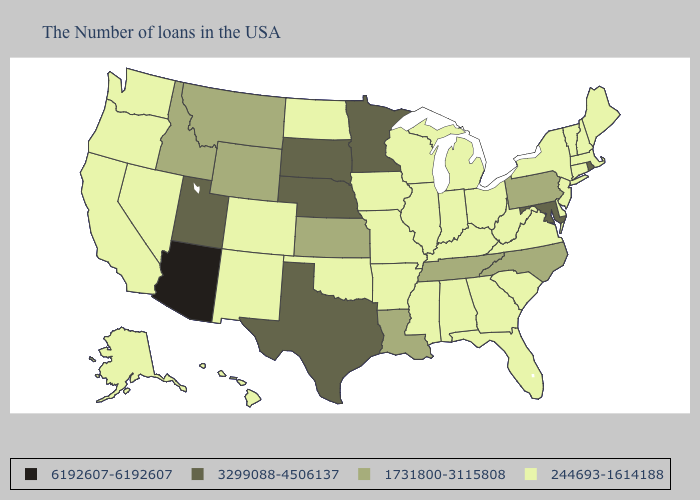What is the lowest value in states that border Louisiana?
Give a very brief answer. 244693-1614188. Does Texas have the highest value in the South?
Give a very brief answer. Yes. What is the lowest value in states that border Ohio?
Quick response, please. 244693-1614188. Which states hav the highest value in the Northeast?
Give a very brief answer. Rhode Island. What is the highest value in the USA?
Write a very short answer. 6192607-6192607. What is the value of Nevada?
Short answer required. 244693-1614188. Name the states that have a value in the range 3299088-4506137?
Quick response, please. Rhode Island, Maryland, Minnesota, Nebraska, Texas, South Dakota, Utah. Which states have the highest value in the USA?
Concise answer only. Arizona. How many symbols are there in the legend?
Answer briefly. 4. Does the first symbol in the legend represent the smallest category?
Be succinct. No. How many symbols are there in the legend?
Concise answer only. 4. Does Virginia have the same value as Rhode Island?
Short answer required. No. Which states have the lowest value in the South?
Concise answer only. Delaware, Virginia, South Carolina, West Virginia, Florida, Georgia, Kentucky, Alabama, Mississippi, Arkansas, Oklahoma. Name the states that have a value in the range 3299088-4506137?
Answer briefly. Rhode Island, Maryland, Minnesota, Nebraska, Texas, South Dakota, Utah. 